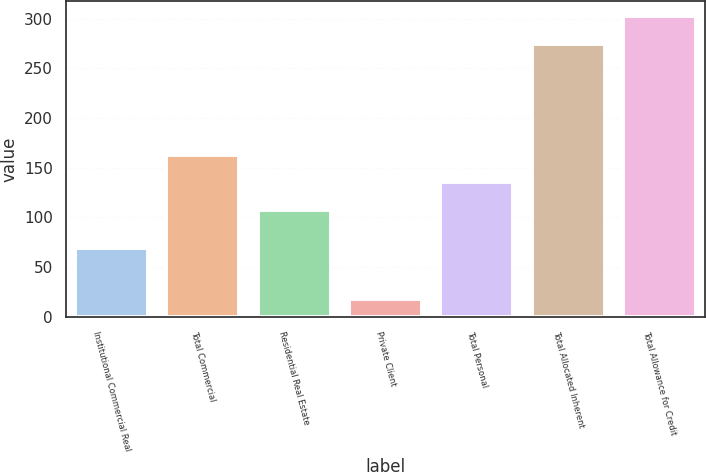<chart> <loc_0><loc_0><loc_500><loc_500><bar_chart><fcel>Institutional Commercial Real<fcel>Total Commercial<fcel>Residential Real Estate<fcel>Private Client<fcel>Total Personal<fcel>Total Allocated Inherent<fcel>Total Allowance for Credit<nl><fcel>69.4<fcel>163.32<fcel>107.7<fcel>17.8<fcel>135.51<fcel>274.8<fcel>302.61<nl></chart> 